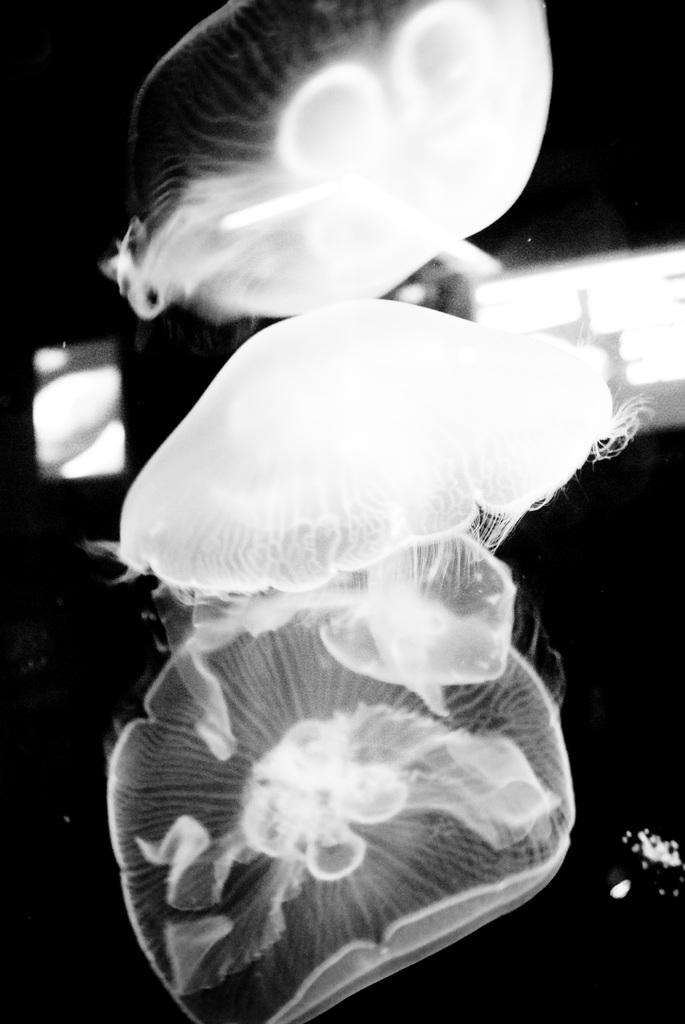What is the color scheme of the image? The image is black and white. What type of sea creatures can be seen in the image? There are jellyfishes in the image. How would you describe the background of the image? The background of the image is dark. Where is the throne located in the image? There is no throne present in the image. What type of tank can be seen in the image? There is no tank present in the image. 